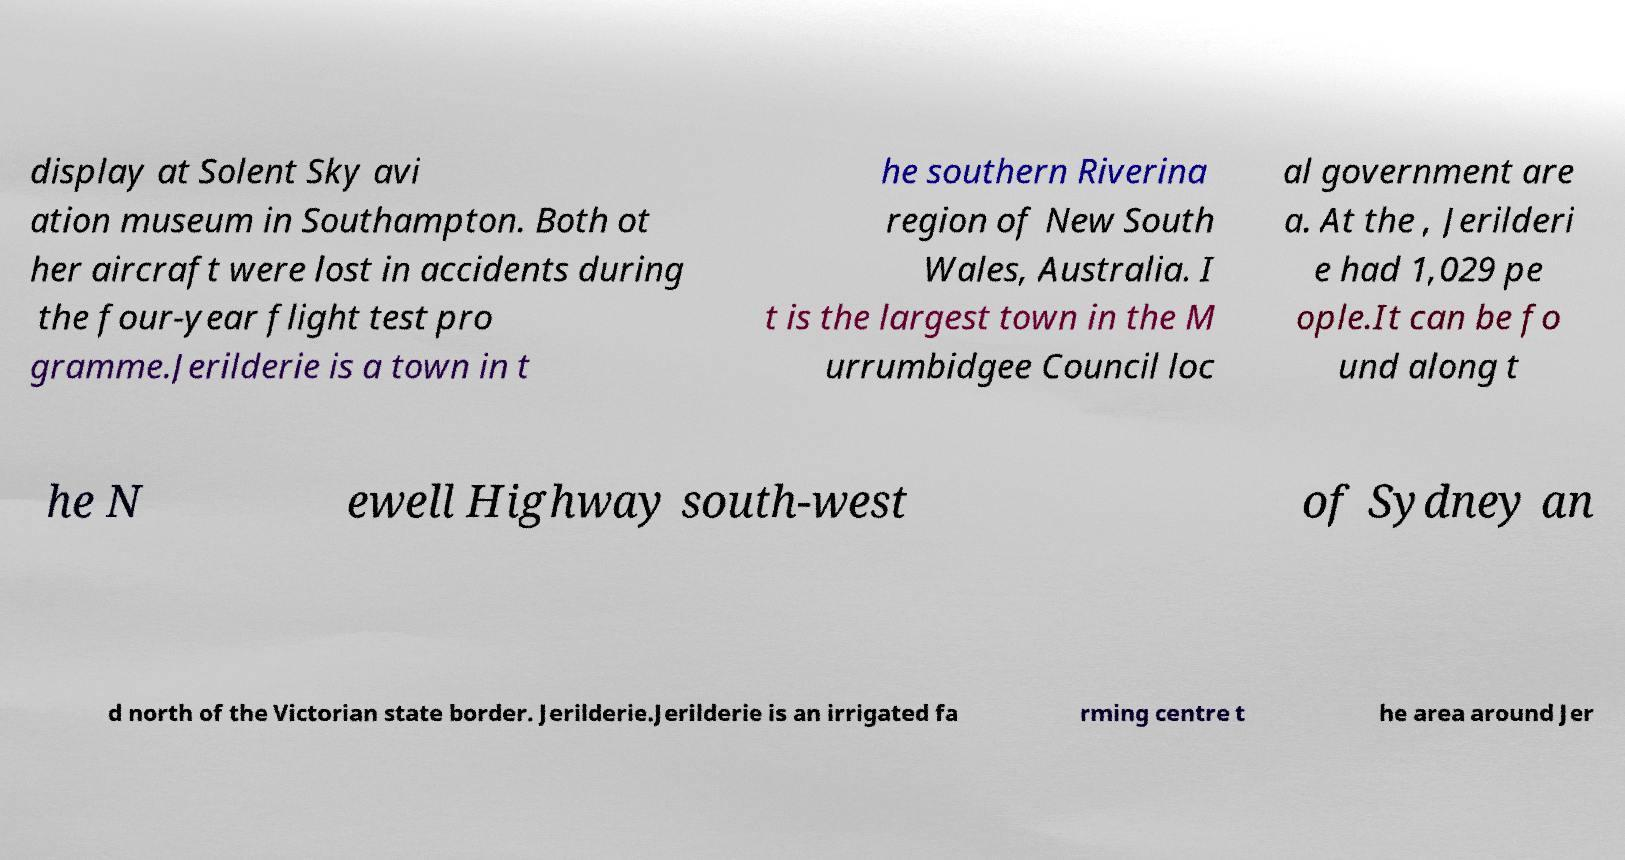Could you assist in decoding the text presented in this image and type it out clearly? display at Solent Sky avi ation museum in Southampton. Both ot her aircraft were lost in accidents during the four-year flight test pro gramme.Jerilderie is a town in t he southern Riverina region of New South Wales, Australia. I t is the largest town in the M urrumbidgee Council loc al government are a. At the , Jerilderi e had 1,029 pe ople.It can be fo und along t he N ewell Highway south-west of Sydney an d north of the Victorian state border. Jerilderie.Jerilderie is an irrigated fa rming centre t he area around Jer 